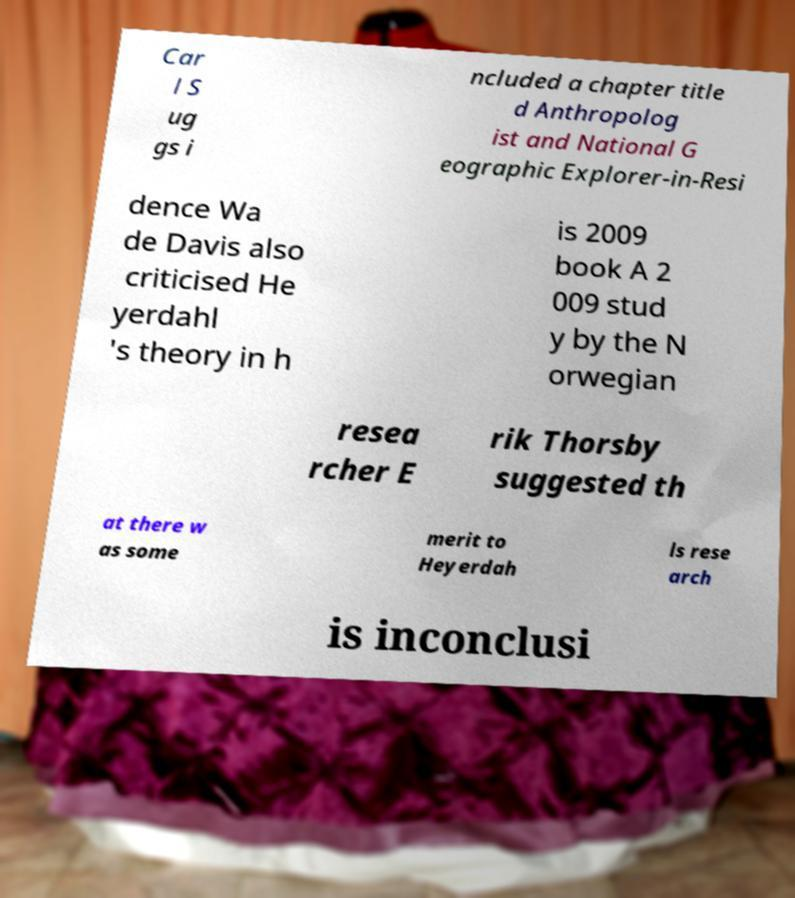Can you accurately transcribe the text from the provided image for me? Car l S ug gs i ncluded a chapter title d Anthropolog ist and National G eographic Explorer-in-Resi dence Wa de Davis also criticised He yerdahl 's theory in h is 2009 book A 2 009 stud y by the N orwegian resea rcher E rik Thorsby suggested th at there w as some merit to Heyerdah ls rese arch is inconclusi 